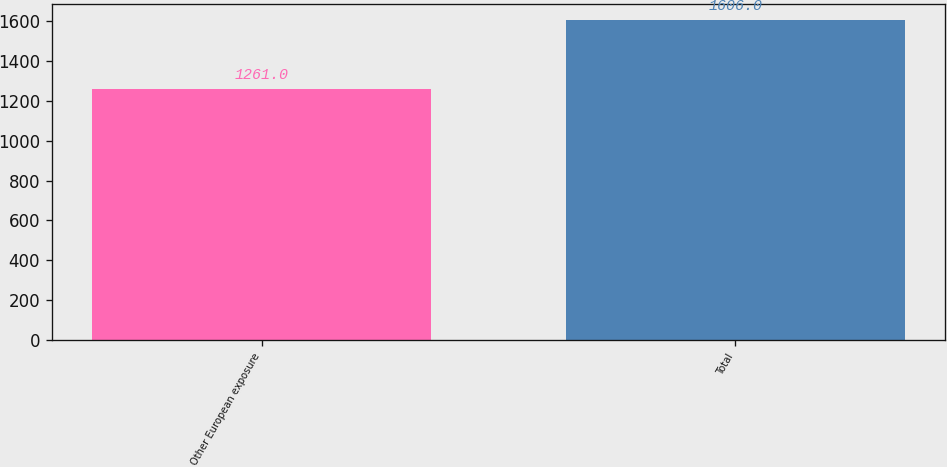Convert chart. <chart><loc_0><loc_0><loc_500><loc_500><bar_chart><fcel>Other European exposure<fcel>Total<nl><fcel>1261<fcel>1606<nl></chart> 